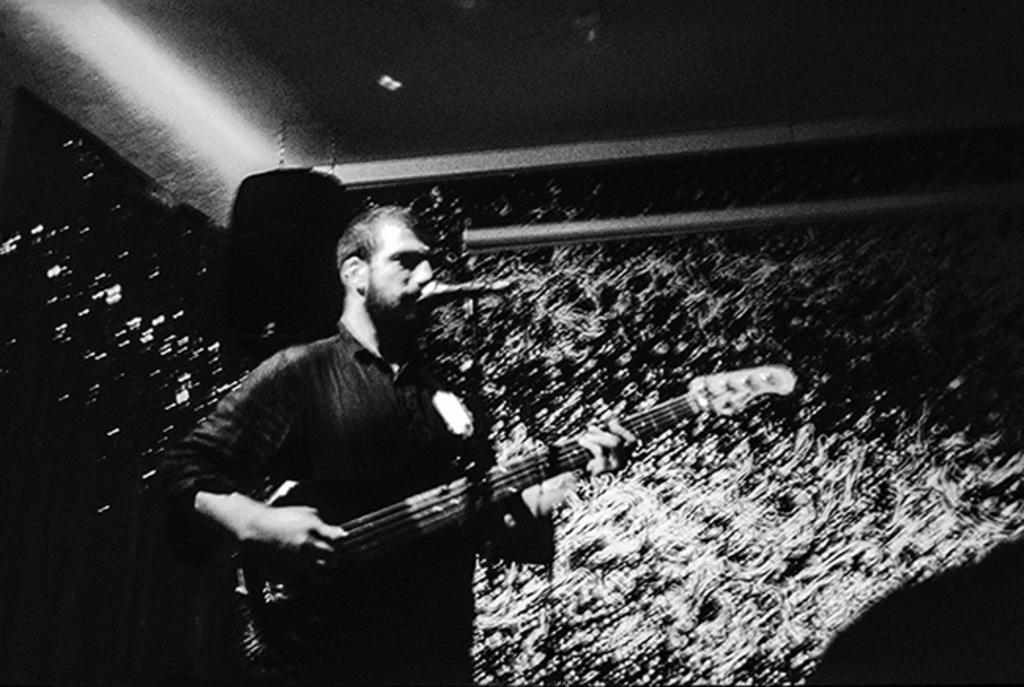Who is the main subject in the image? There is a man in the image. What is the man holding in the image? The man is holding a guitar. What is the man doing with the microphone in the image? The man is singing through a microphone. What type of pleasure can be seen in the man's face while he is singing in the image? There is no indication of the man's facial expression in the image, so it cannot be determined if he is experiencing pleasure or any other emotion. 